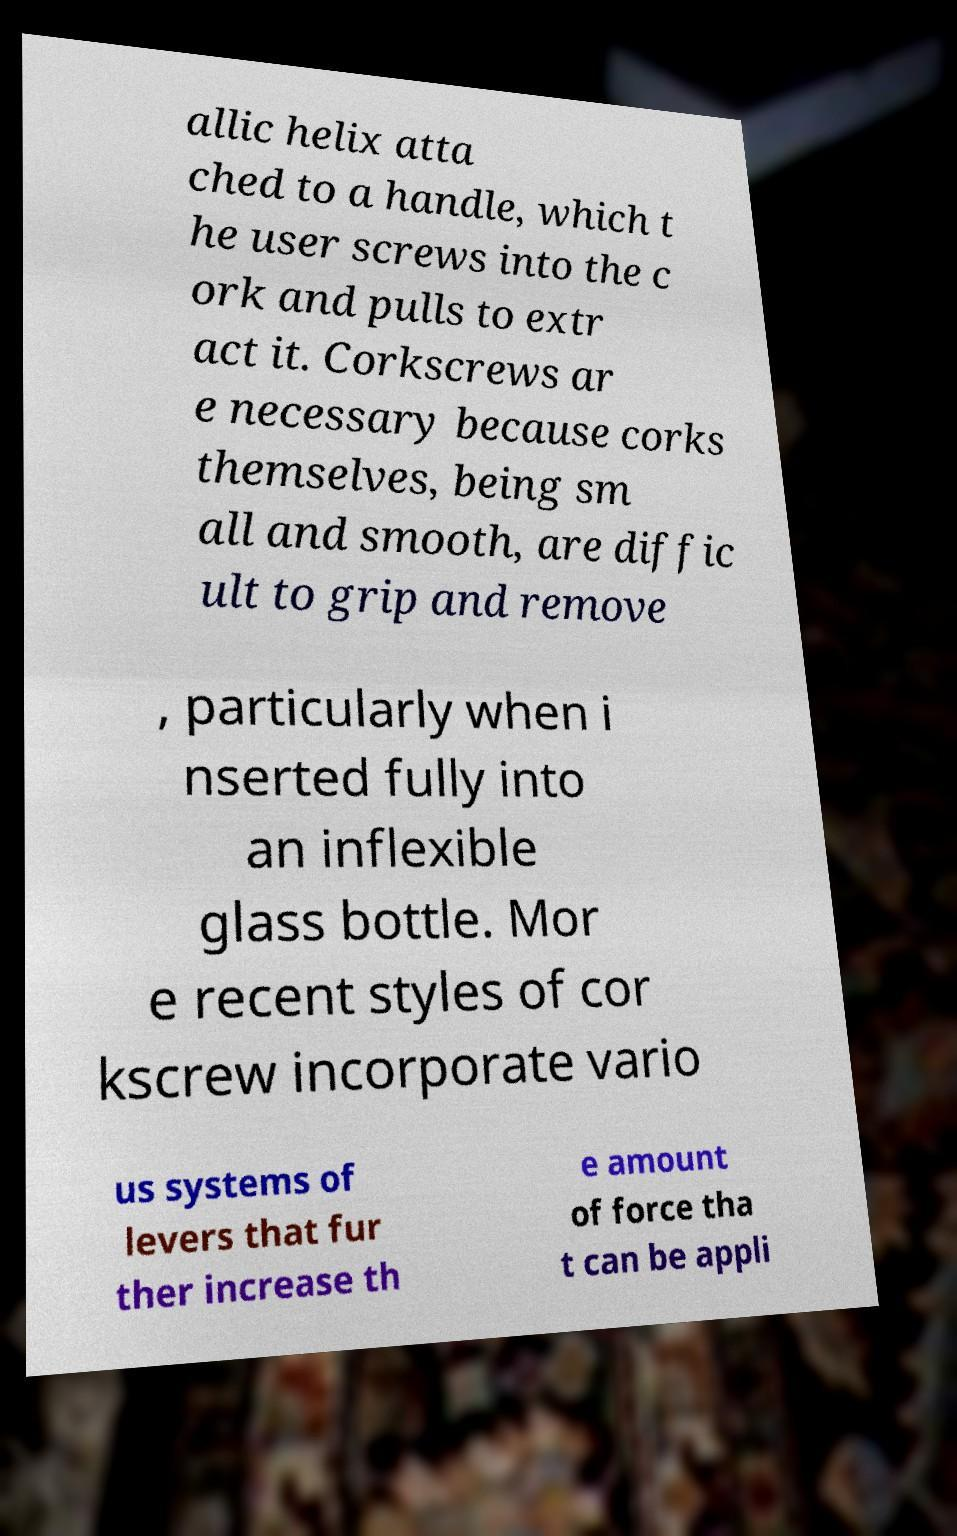Can you accurately transcribe the text from the provided image for me? allic helix atta ched to a handle, which t he user screws into the c ork and pulls to extr act it. Corkscrews ar e necessary because corks themselves, being sm all and smooth, are diffic ult to grip and remove , particularly when i nserted fully into an inflexible glass bottle. Mor e recent styles of cor kscrew incorporate vario us systems of levers that fur ther increase th e amount of force tha t can be appli 